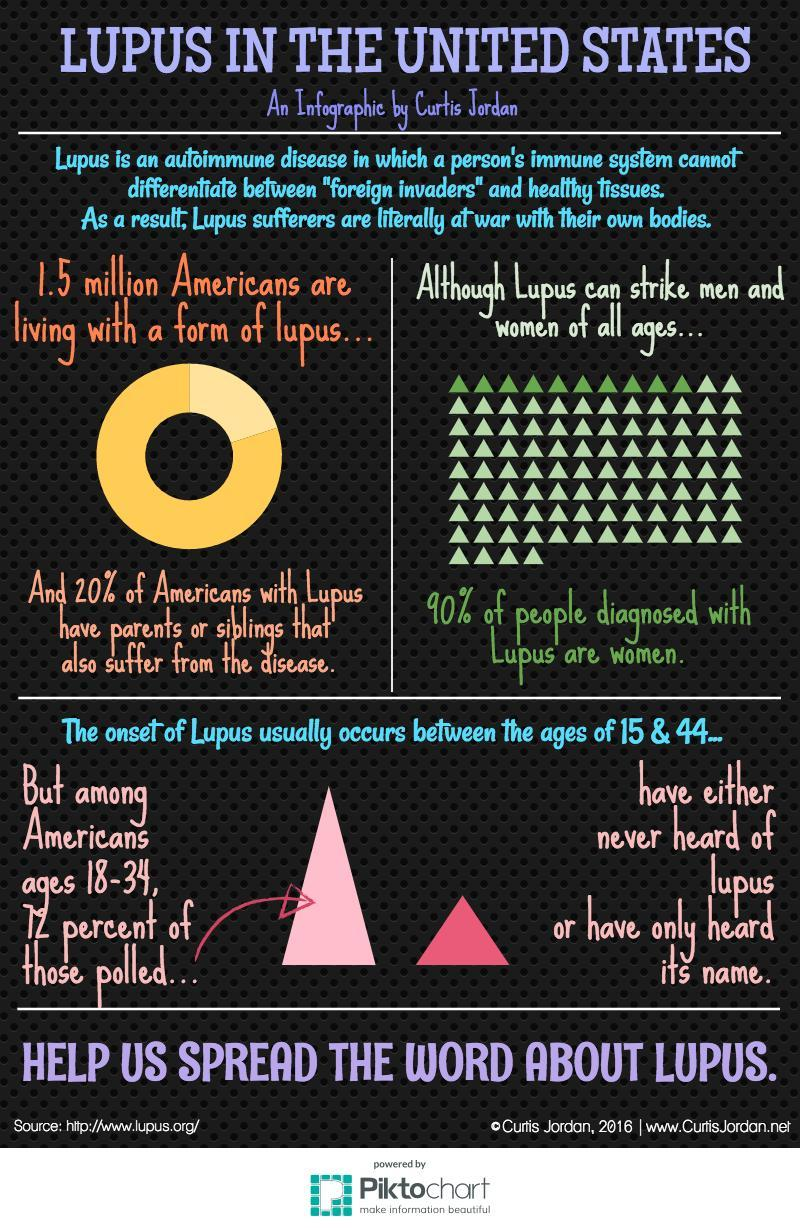What is the no of americans affected by lupus?
Answer the question with a short phrase. 1.5 million What percent of americans with lupus are as a result of genetical inheritance? 20% What percent of people diagnosed with lupus are men in U.S.? 10% 